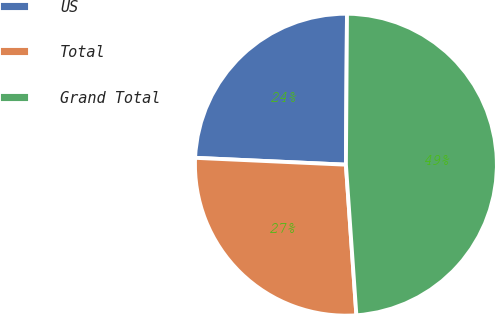<chart> <loc_0><loc_0><loc_500><loc_500><pie_chart><fcel>US<fcel>Total<fcel>Grand Total<nl><fcel>24.39%<fcel>26.83%<fcel>48.78%<nl></chart> 